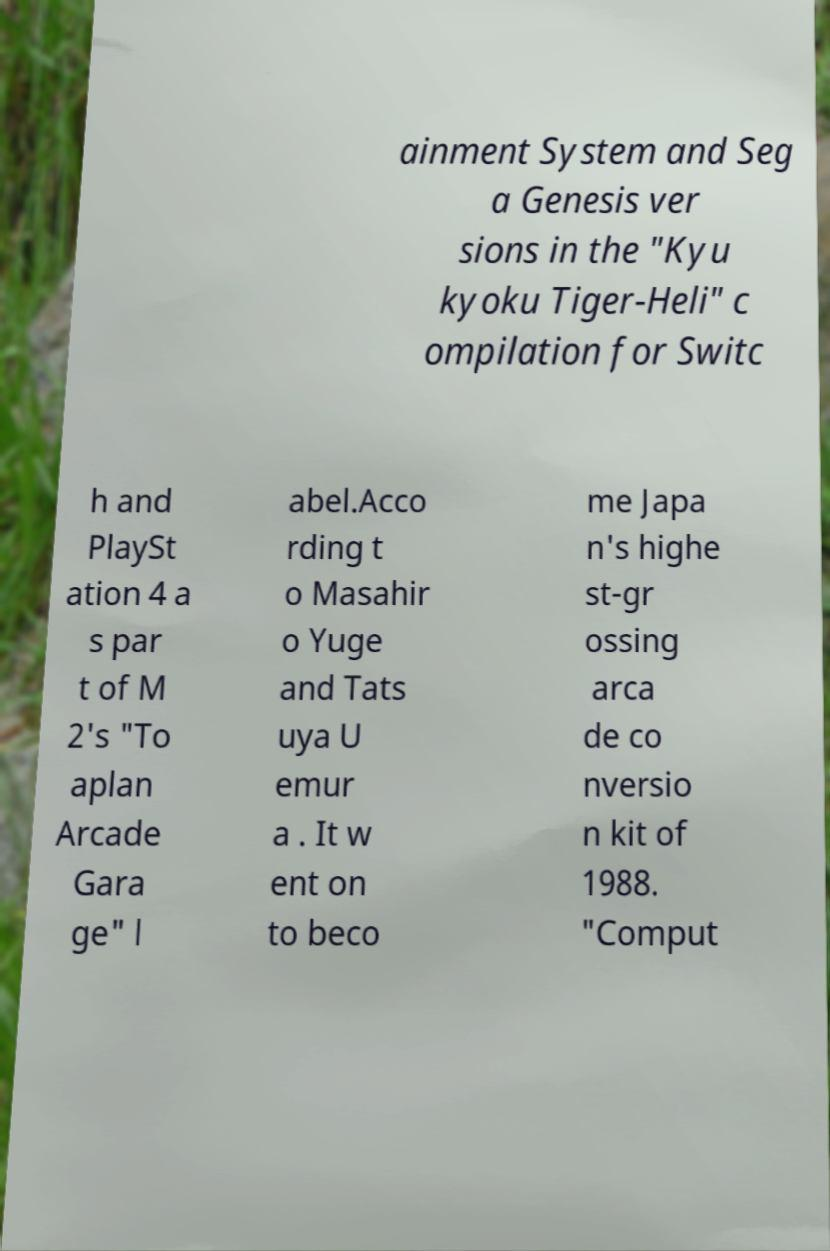Please read and relay the text visible in this image. What does it say? ainment System and Seg a Genesis ver sions in the "Kyu kyoku Tiger-Heli" c ompilation for Switc h and PlaySt ation 4 a s par t of M 2's "To aplan Arcade Gara ge" l abel.Acco rding t o Masahir o Yuge and Tats uya U emur a . It w ent on to beco me Japa n's highe st-gr ossing arca de co nversio n kit of 1988. "Comput 